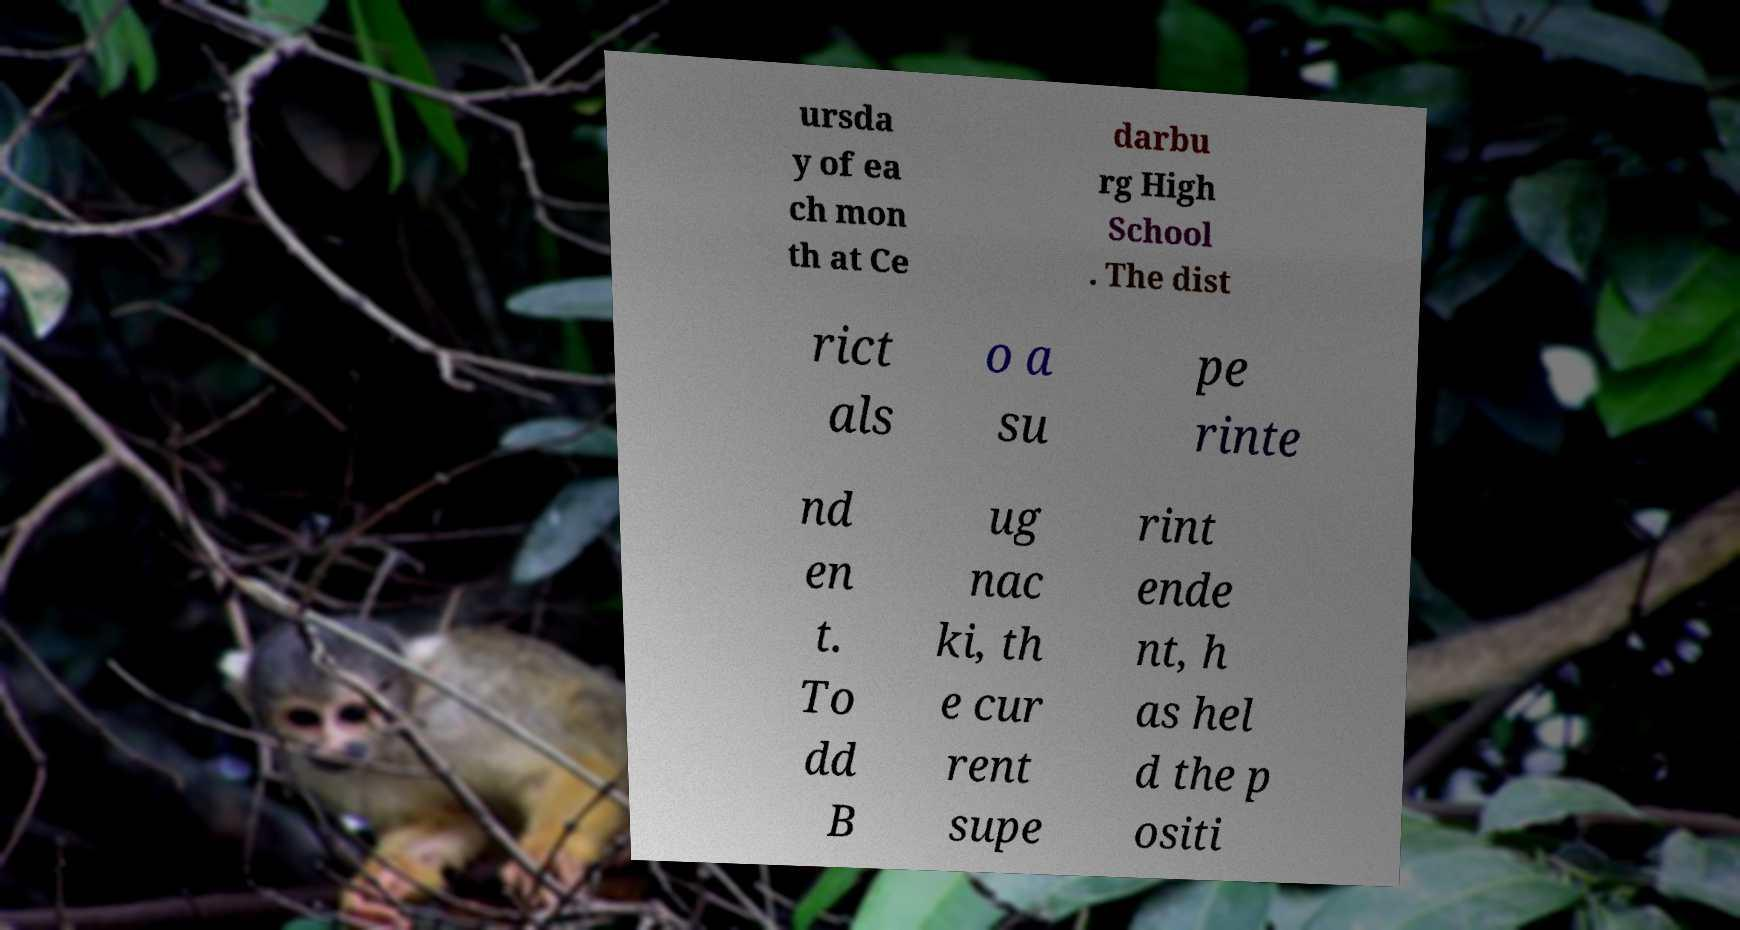For documentation purposes, I need the text within this image transcribed. Could you provide that? ursda y of ea ch mon th at Ce darbu rg High School . The dist rict als o a su pe rinte nd en t. To dd B ug nac ki, th e cur rent supe rint ende nt, h as hel d the p ositi 